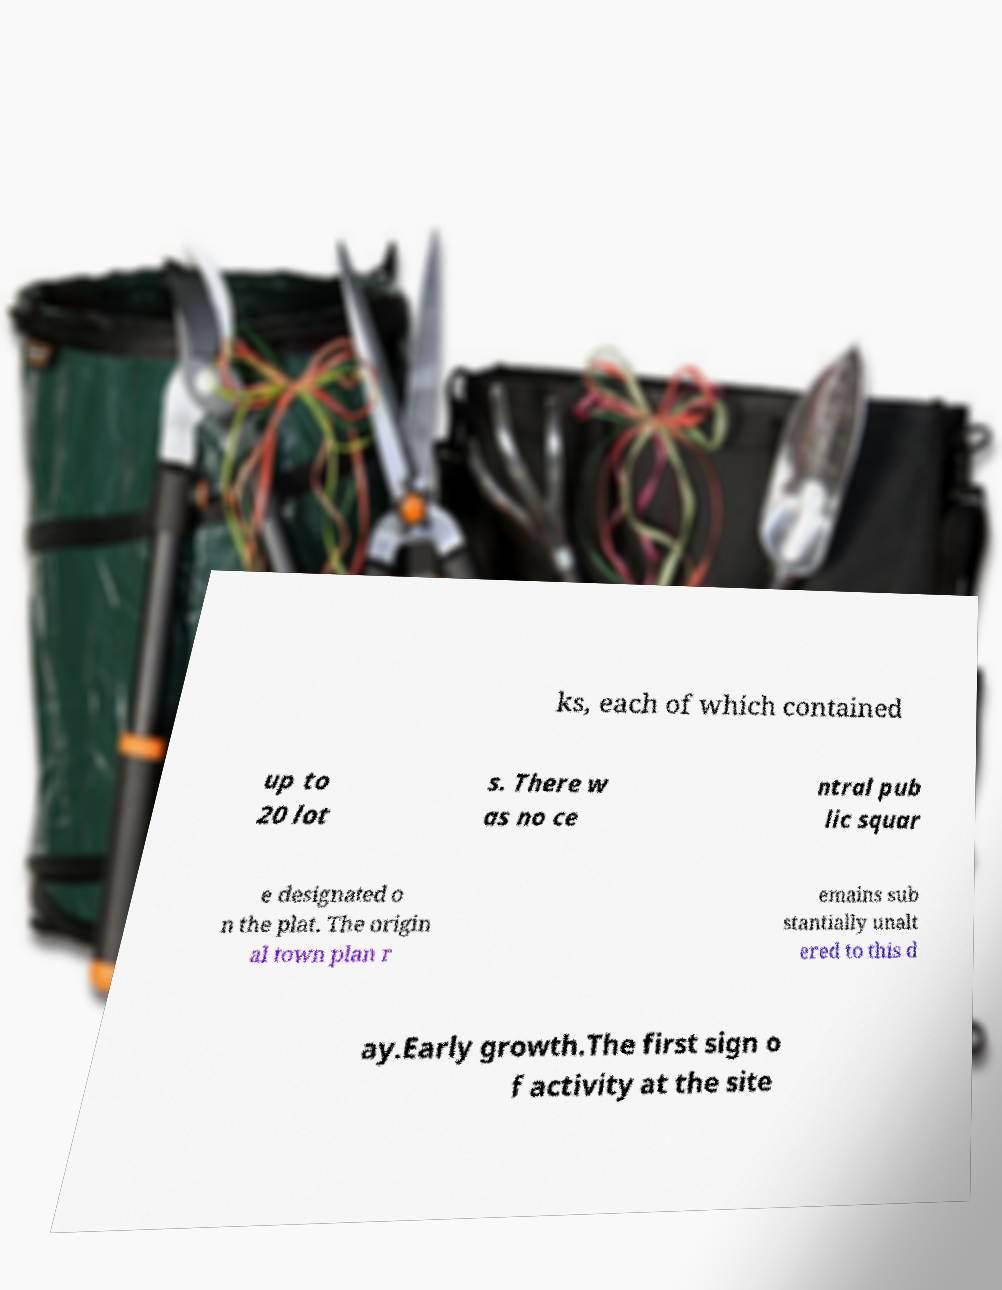For documentation purposes, I need the text within this image transcribed. Could you provide that? ks, each of which contained up to 20 lot s. There w as no ce ntral pub lic squar e designated o n the plat. The origin al town plan r emains sub stantially unalt ered to this d ay.Early growth.The first sign o f activity at the site 